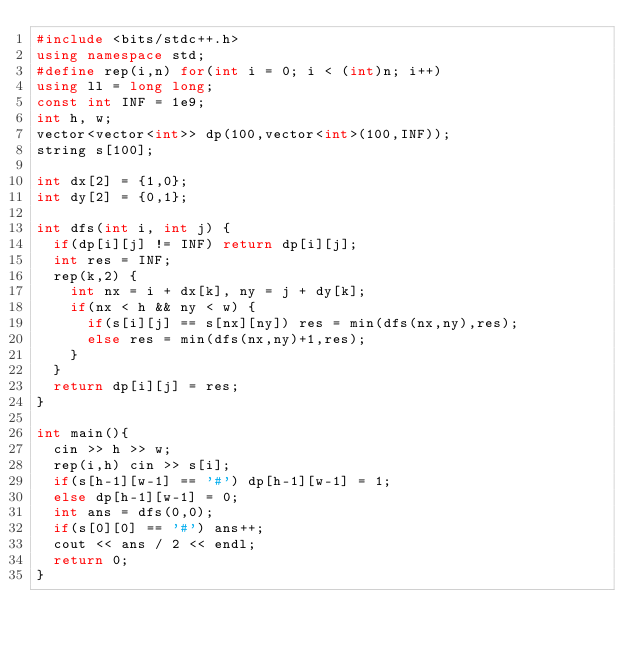Convert code to text. <code><loc_0><loc_0><loc_500><loc_500><_C++_>#include <bits/stdc++.h>
using namespace std;
#define rep(i,n) for(int i = 0; i < (int)n; i++)
using ll = long long;
const int INF = 1e9;
int h, w;
vector<vector<int>> dp(100,vector<int>(100,INF));
string s[100];

int dx[2] = {1,0};
int dy[2] = {0,1};

int dfs(int i, int j) {
  if(dp[i][j] != INF) return dp[i][j];
  int res = INF;
  rep(k,2) {
    int nx = i + dx[k], ny = j + dy[k];
    if(nx < h && ny < w) {
      if(s[i][j] == s[nx][ny]) res = min(dfs(nx,ny),res);
      else res = min(dfs(nx,ny)+1,res);
    }
  }
  return dp[i][j] = res; 
}

int main(){
  cin >> h >> w;
  rep(i,h) cin >> s[i];
  if(s[h-1][w-1] == '#') dp[h-1][w-1] = 1;
  else dp[h-1][w-1] = 0;
  int ans = dfs(0,0);
  if(s[0][0] == '#') ans++;
  cout << ans / 2 << endl;
  return 0;
}
</code> 